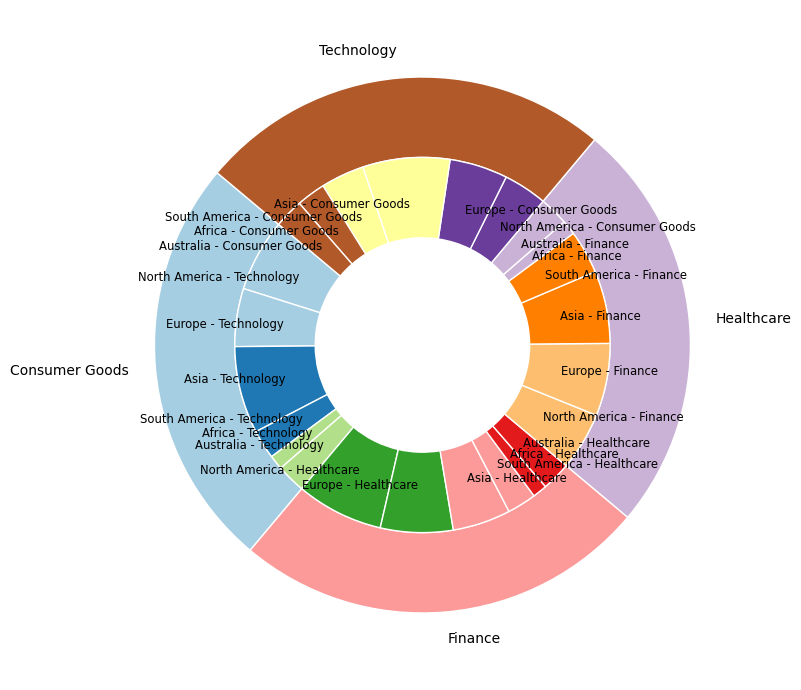What's the total market share for the Finance industry? Sum up the market shares of the Finance industry across all regions: 20 (North America) + 25 (Europe) + 25 (Asia) + 15 (South America) + 5 (Africa) + 10 (Australia) = 100
Answer: 100 Which industry has the highest market share overall? Compare the summed market shares of all industries: Technology (100), Healthcare (100), Finance (100), Consumer Goods (100). They all total to 100, thus no industry has the highest market share if looking purely at the numerical distribution.
Answer: All equal What is the market share breakdown of Technology in Asia? Identify the inner segment labeled "Asia - Technology" in the inner pie. The market share for Technology in Asia is 30.
Answer: 30 Which region contributes the least to the Consumer Goods market share? Look at the inner pie segments for "Consumer Goods" and find the smallest value. Africa contributes 10, which is less than the other regions.
Answer: Africa How does the market share of Healthcare in North America compare to that in Asia? Compare the inner pie segments "North America - Healthcare" (30) and "Asia - Healthcare" (20). North America's share (30) is larger than Asia's share (20).
Answer: North America has a higher share What’s the sum of market shares for all industries in South America? Sum up the market shares of each industry in South America: Technology (10) + Healthcare (10) + Finance (15) + Consumer Goods (15). Total is 10 + 10 + 15 + 15 = 50.
Answer: 50 What is the combined market share of Healthcare and Finance in Europe? Sum the market shares of Healthcare and Finance in Europe: Healthcare (25) + Finance (25) = 50.
Answer: 50 Which region has a balanced distribution of market shares across different industries, with each industry contributing 10%? Visually inspect the inner pie chart for any region with equal shares: None of the regions show this exact balance; however, all industries have same aggregate market share of 100 each.
Answer: None How much larger is the market share of Technology in Europe compared to that in Australia? Subtract the market share of Technology in Australia from that in Europe: 20 (Europe) - 10 (Australia) = 10.
Answer: 10 What percentage of the total market share does Asia represent for the Consumer Goods industry? Identify "Asia - Consumer Goods" (30), and divide by the total market share for Consumer Goods industry (100), then multiply by 100 to get the percentage: (30 / 100) * 100 = 30%.
Answer: 30% 